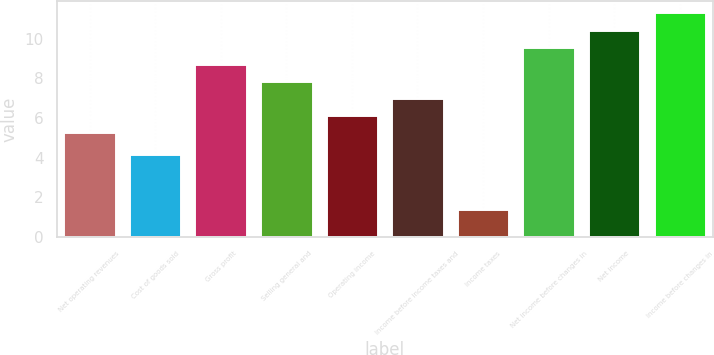<chart> <loc_0><loc_0><loc_500><loc_500><bar_chart><fcel>Net operating revenues<fcel>Cost of goods sold<fcel>Gross profit<fcel>Selling general and<fcel>Operating income<fcel>Income before income taxes and<fcel>Income taxes<fcel>Net income before changes in<fcel>Net income<fcel>Income before changes in<nl><fcel>5.3<fcel>4.2<fcel>8.74<fcel>7.88<fcel>6.16<fcel>7.02<fcel>1.4<fcel>9.6<fcel>10.46<fcel>11.32<nl></chart> 